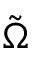Convert formula to latex. <formula><loc_0><loc_0><loc_500><loc_500>\tilde { \Omega }</formula> 